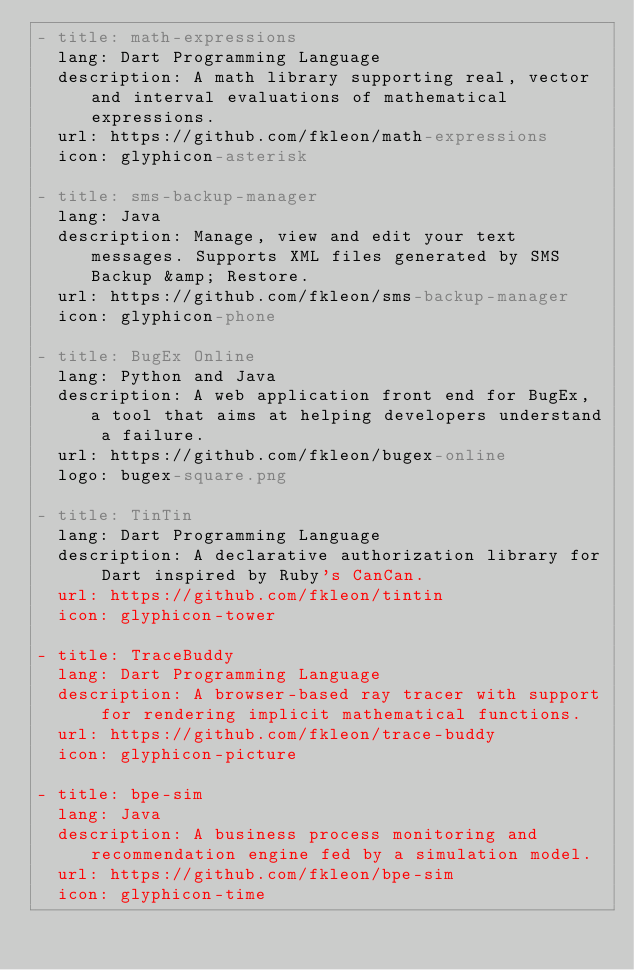Convert code to text. <code><loc_0><loc_0><loc_500><loc_500><_YAML_>- title: math-expressions
  lang: Dart Programming Language
  description: A math library supporting real, vector and interval evaluations of mathematical expressions.
  url: https://github.com/fkleon/math-expressions
  icon: glyphicon-asterisk

- title: sms-backup-manager
  lang: Java
  description: Manage, view and edit your text messages. Supports XML files generated by SMS Backup &amp; Restore.
  url: https://github.com/fkleon/sms-backup-manager
  icon: glyphicon-phone

- title: BugEx Online
  lang: Python and Java
  description: A web application front end for BugEx, a tool that aims at helping developers understand a failure.
  url: https://github.com/fkleon/bugex-online
  logo: bugex-square.png

- title: TinTin
  lang: Dart Programming Language
  description: A declarative authorization library for Dart inspired by Ruby's CanCan.
  url: https://github.com/fkleon/tintin
  icon: glyphicon-tower

- title: TraceBuddy
  lang: Dart Programming Language
  description: A browser-based ray tracer with support for rendering implicit mathematical functions.
  url: https://github.com/fkleon/trace-buddy
  icon: glyphicon-picture

- title: bpe-sim
  lang: Java
  description: A business process monitoring and recommendation engine fed by a simulation model.
  url: https://github.com/fkleon/bpe-sim
  icon: glyphicon-time
</code> 